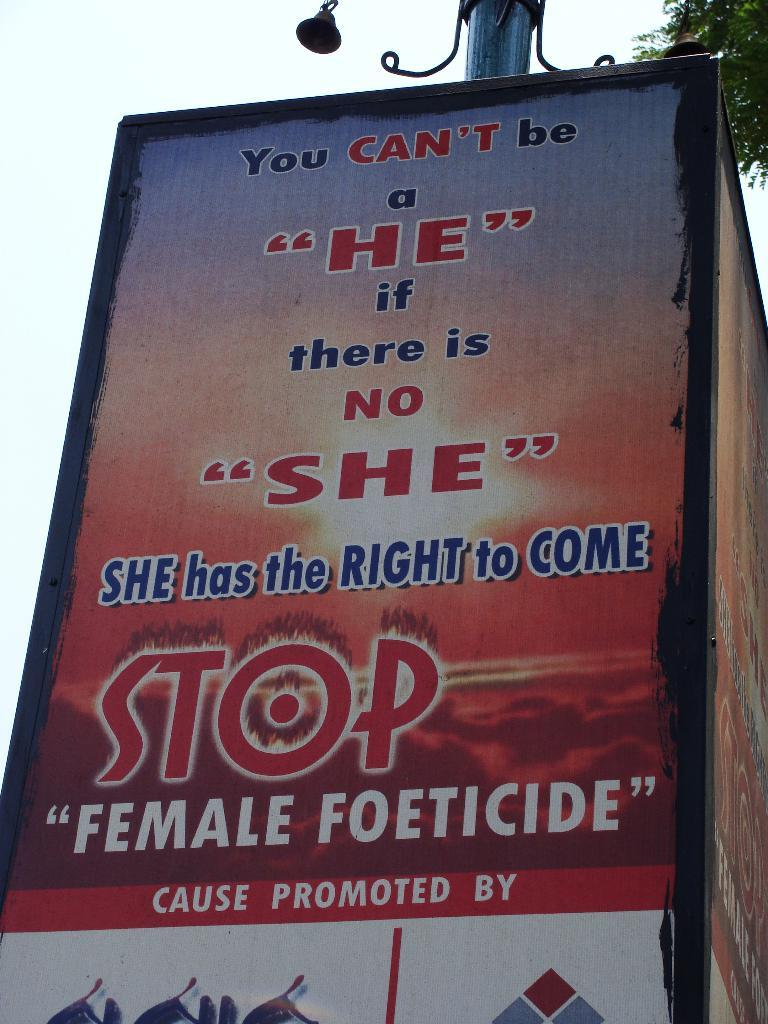<image>
Describe the image concisely. Big sign that is promoting female rights on a poster 